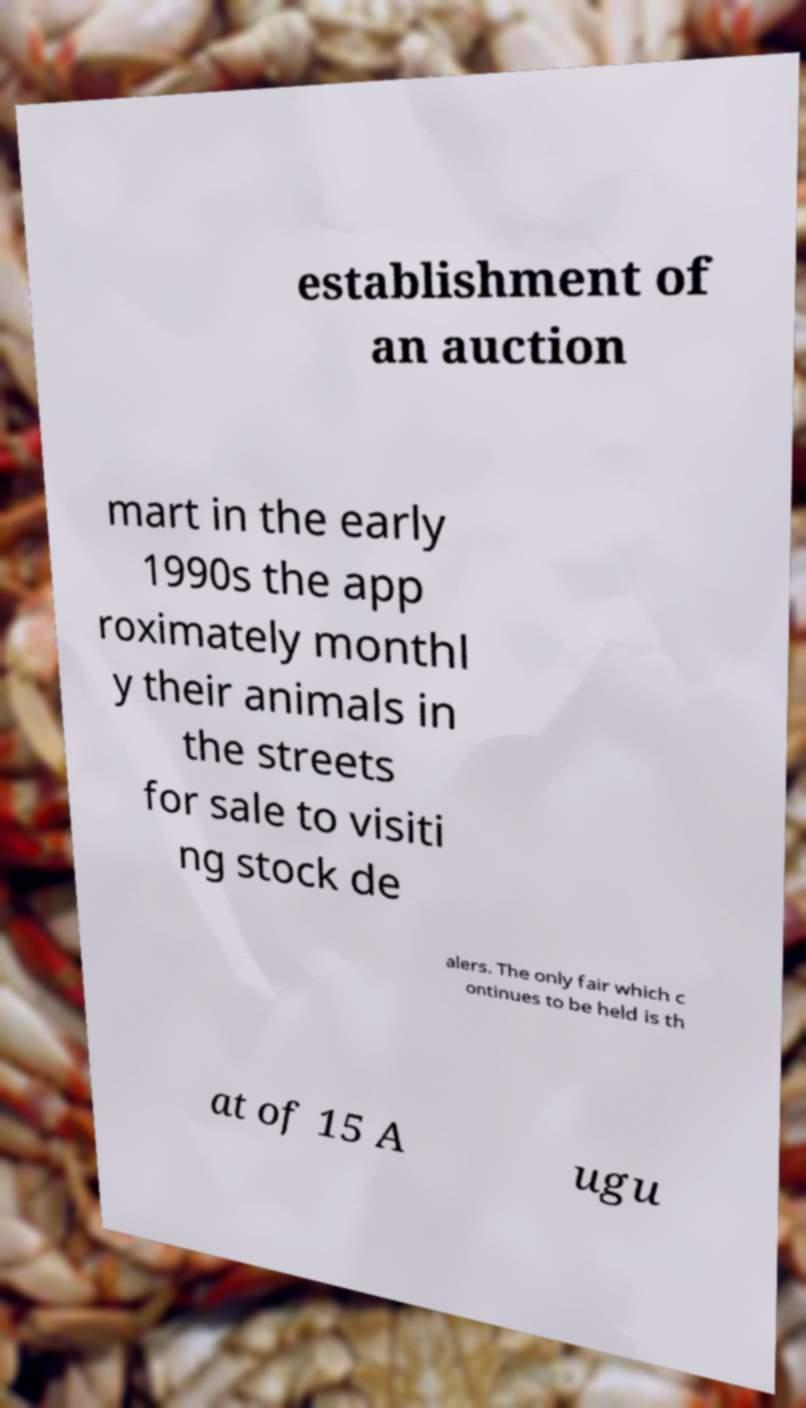Can you read and provide the text displayed in the image?This photo seems to have some interesting text. Can you extract and type it out for me? establishment of an auction mart in the early 1990s the app roximately monthl y their animals in the streets for sale to visiti ng stock de alers. The only fair which c ontinues to be held is th at of 15 A ugu 